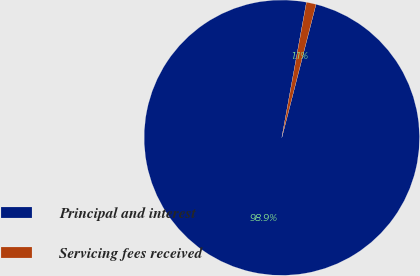Convert chart to OTSL. <chart><loc_0><loc_0><loc_500><loc_500><pie_chart><fcel>Principal and interest<fcel>Servicing fees received<nl><fcel>98.87%<fcel>1.13%<nl></chart> 